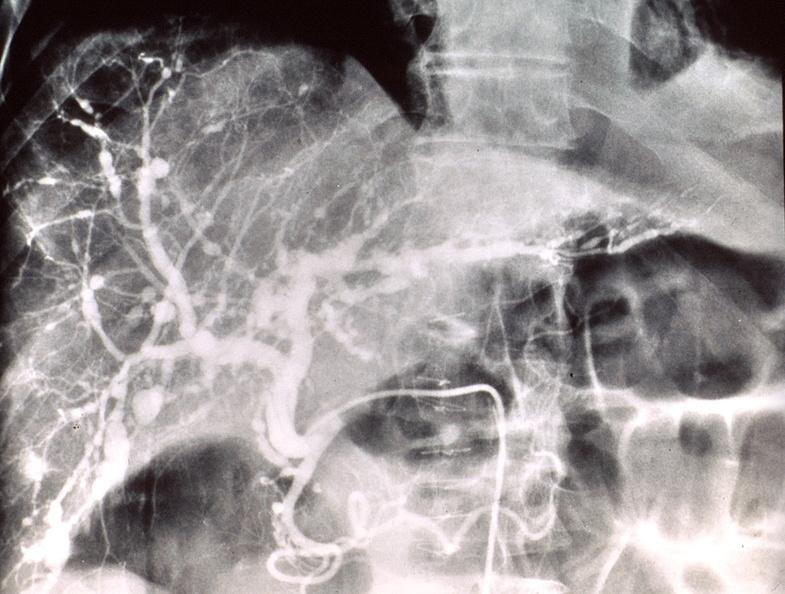does bone, mandible show poly arteritis nodosa, liver?
Answer the question using a single word or phrase. No 